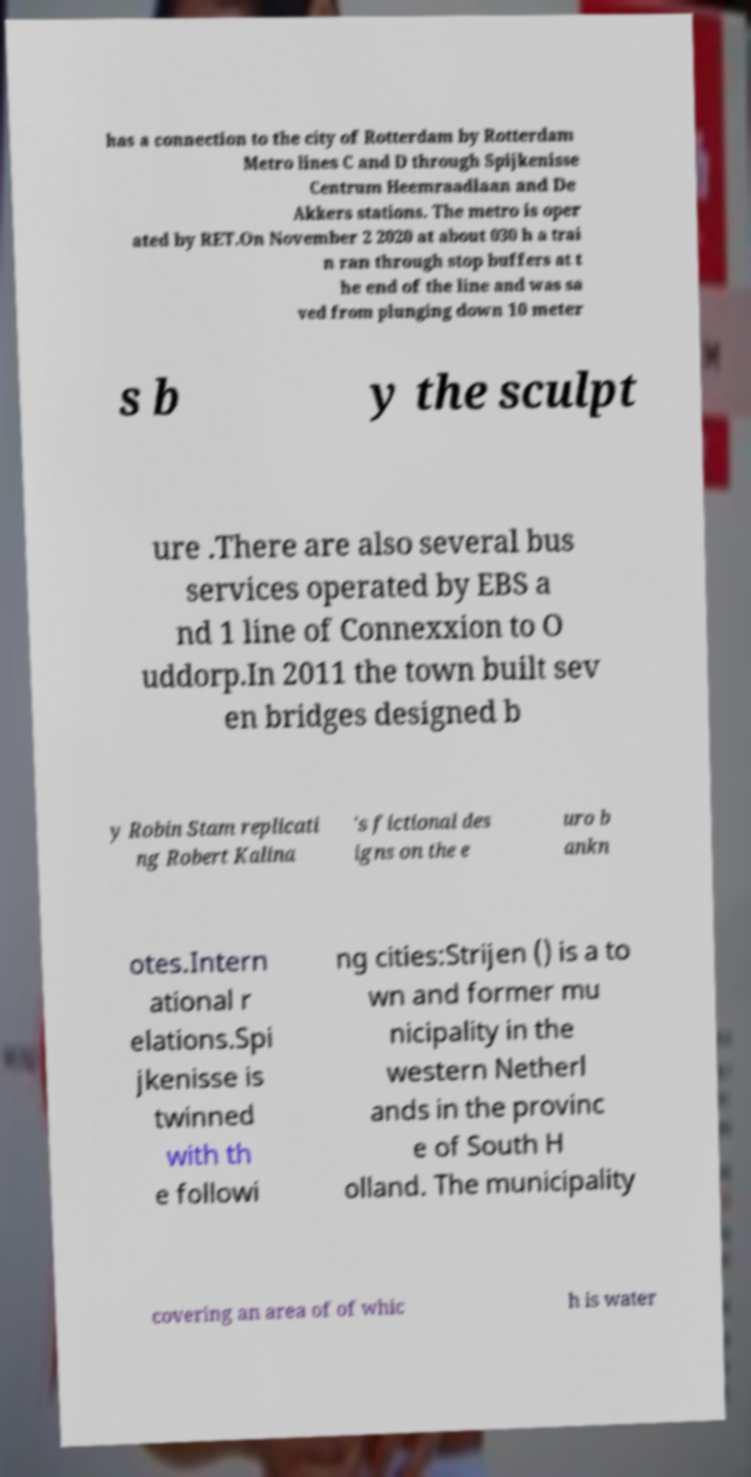What messages or text are displayed in this image? I need them in a readable, typed format. has a connection to the city of Rotterdam by Rotterdam Metro lines C and D through Spijkenisse Centrum Heemraadlaan and De Akkers stations. The metro is oper ated by RET.On November 2 2020 at about 030 h a trai n ran through stop buffers at t he end of the line and was sa ved from plunging down 10 meter s b y the sculpt ure .There are also several bus services operated by EBS a nd 1 line of Connexxion to O uddorp.In 2011 the town built sev en bridges designed b y Robin Stam replicati ng Robert Kalina 's fictional des igns on the e uro b ankn otes.Intern ational r elations.Spi jkenisse is twinned with th e followi ng cities:Strijen () is a to wn and former mu nicipality in the western Netherl ands in the provinc e of South H olland. The municipality covering an area of of whic h is water 